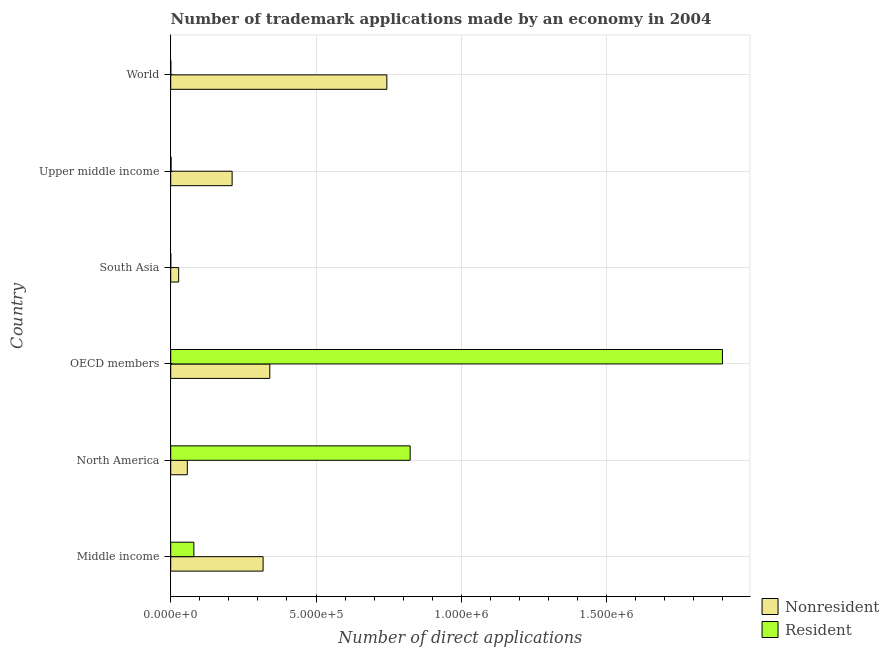How many groups of bars are there?
Keep it short and to the point. 6. Are the number of bars per tick equal to the number of legend labels?
Ensure brevity in your answer.  Yes. Are the number of bars on each tick of the Y-axis equal?
Offer a very short reply. Yes. How many bars are there on the 2nd tick from the bottom?
Your answer should be very brief. 2. In how many cases, is the number of bars for a given country not equal to the number of legend labels?
Provide a succinct answer. 0. What is the number of trademark applications made by residents in World?
Make the answer very short. 202. Across all countries, what is the maximum number of trademark applications made by non residents?
Offer a terse response. 7.44e+05. Across all countries, what is the minimum number of trademark applications made by residents?
Your answer should be compact. 128. In which country was the number of trademark applications made by non residents maximum?
Your response must be concise. World. What is the total number of trademark applications made by residents in the graph?
Make the answer very short. 2.80e+06. What is the difference between the number of trademark applications made by non residents in South Asia and that in Upper middle income?
Offer a terse response. -1.84e+05. What is the difference between the number of trademark applications made by residents in World and the number of trademark applications made by non residents in OECD members?
Your response must be concise. -3.41e+05. What is the average number of trademark applications made by non residents per country?
Keep it short and to the point. 2.83e+05. What is the difference between the number of trademark applications made by residents and number of trademark applications made by non residents in Middle income?
Keep it short and to the point. -2.38e+05. In how many countries, is the number of trademark applications made by residents greater than 600000 ?
Make the answer very short. 2. What is the ratio of the number of trademark applications made by non residents in North America to that in World?
Make the answer very short. 0.08. Is the number of trademark applications made by residents in OECD members less than that in South Asia?
Your answer should be compact. No. Is the difference between the number of trademark applications made by residents in North America and Upper middle income greater than the difference between the number of trademark applications made by non residents in North America and Upper middle income?
Your answer should be compact. Yes. What is the difference between the highest and the second highest number of trademark applications made by non residents?
Give a very brief answer. 4.03e+05. What is the difference between the highest and the lowest number of trademark applications made by non residents?
Give a very brief answer. 7.16e+05. In how many countries, is the number of trademark applications made by residents greater than the average number of trademark applications made by residents taken over all countries?
Give a very brief answer. 2. What does the 1st bar from the top in OECD members represents?
Keep it short and to the point. Resident. What does the 1st bar from the bottom in World represents?
Make the answer very short. Nonresident. How many bars are there?
Provide a short and direct response. 12. How many countries are there in the graph?
Ensure brevity in your answer.  6. What is the difference between two consecutive major ticks on the X-axis?
Provide a succinct answer. 5.00e+05. Are the values on the major ticks of X-axis written in scientific E-notation?
Make the answer very short. Yes. Does the graph contain any zero values?
Your answer should be very brief. No. Does the graph contain grids?
Keep it short and to the point. Yes. Where does the legend appear in the graph?
Keep it short and to the point. Bottom right. How many legend labels are there?
Your answer should be very brief. 2. How are the legend labels stacked?
Make the answer very short. Vertical. What is the title of the graph?
Keep it short and to the point. Number of trademark applications made by an economy in 2004. Does "Under-5(male)" appear as one of the legend labels in the graph?
Provide a succinct answer. No. What is the label or title of the X-axis?
Offer a very short reply. Number of direct applications. What is the Number of direct applications of Nonresident in Middle income?
Make the answer very short. 3.18e+05. What is the Number of direct applications in Resident in Middle income?
Offer a very short reply. 7.97e+04. What is the Number of direct applications in Nonresident in North America?
Offer a very short reply. 5.71e+04. What is the Number of direct applications in Resident in North America?
Your response must be concise. 8.24e+05. What is the Number of direct applications in Nonresident in OECD members?
Offer a terse response. 3.41e+05. What is the Number of direct applications in Resident in OECD members?
Your answer should be compact. 1.90e+06. What is the Number of direct applications in Nonresident in South Asia?
Offer a very short reply. 2.73e+04. What is the Number of direct applications of Resident in South Asia?
Give a very brief answer. 128. What is the Number of direct applications in Nonresident in Upper middle income?
Offer a terse response. 2.11e+05. What is the Number of direct applications in Resident in Upper middle income?
Offer a terse response. 1266. What is the Number of direct applications of Nonresident in World?
Make the answer very short. 7.44e+05. What is the Number of direct applications in Resident in World?
Offer a very short reply. 202. Across all countries, what is the maximum Number of direct applications in Nonresident?
Provide a short and direct response. 7.44e+05. Across all countries, what is the maximum Number of direct applications in Resident?
Offer a terse response. 1.90e+06. Across all countries, what is the minimum Number of direct applications of Nonresident?
Your answer should be very brief. 2.73e+04. Across all countries, what is the minimum Number of direct applications in Resident?
Your answer should be compact. 128. What is the total Number of direct applications in Nonresident in the graph?
Your answer should be compact. 1.70e+06. What is the total Number of direct applications in Resident in the graph?
Give a very brief answer. 2.80e+06. What is the difference between the Number of direct applications in Nonresident in Middle income and that in North America?
Provide a succinct answer. 2.61e+05. What is the difference between the Number of direct applications in Resident in Middle income and that in North America?
Ensure brevity in your answer.  -7.44e+05. What is the difference between the Number of direct applications of Nonresident in Middle income and that in OECD members?
Give a very brief answer. -2.30e+04. What is the difference between the Number of direct applications in Resident in Middle income and that in OECD members?
Keep it short and to the point. -1.82e+06. What is the difference between the Number of direct applications of Nonresident in Middle income and that in South Asia?
Your answer should be very brief. 2.91e+05. What is the difference between the Number of direct applications of Resident in Middle income and that in South Asia?
Give a very brief answer. 7.95e+04. What is the difference between the Number of direct applications of Nonresident in Middle income and that in Upper middle income?
Your answer should be very brief. 1.07e+05. What is the difference between the Number of direct applications in Resident in Middle income and that in Upper middle income?
Ensure brevity in your answer.  7.84e+04. What is the difference between the Number of direct applications of Nonresident in Middle income and that in World?
Ensure brevity in your answer.  -4.26e+05. What is the difference between the Number of direct applications in Resident in Middle income and that in World?
Provide a short and direct response. 7.95e+04. What is the difference between the Number of direct applications of Nonresident in North America and that in OECD members?
Provide a succinct answer. -2.84e+05. What is the difference between the Number of direct applications in Resident in North America and that in OECD members?
Provide a succinct answer. -1.07e+06. What is the difference between the Number of direct applications in Nonresident in North America and that in South Asia?
Provide a succinct answer. 2.97e+04. What is the difference between the Number of direct applications of Resident in North America and that in South Asia?
Ensure brevity in your answer.  8.24e+05. What is the difference between the Number of direct applications in Nonresident in North America and that in Upper middle income?
Offer a terse response. -1.54e+05. What is the difference between the Number of direct applications in Resident in North America and that in Upper middle income?
Make the answer very short. 8.23e+05. What is the difference between the Number of direct applications in Nonresident in North America and that in World?
Make the answer very short. -6.87e+05. What is the difference between the Number of direct applications in Resident in North America and that in World?
Make the answer very short. 8.24e+05. What is the difference between the Number of direct applications of Nonresident in OECD members and that in South Asia?
Provide a short and direct response. 3.14e+05. What is the difference between the Number of direct applications in Resident in OECD members and that in South Asia?
Make the answer very short. 1.90e+06. What is the difference between the Number of direct applications of Nonresident in OECD members and that in Upper middle income?
Provide a succinct answer. 1.30e+05. What is the difference between the Number of direct applications of Resident in OECD members and that in Upper middle income?
Your response must be concise. 1.90e+06. What is the difference between the Number of direct applications of Nonresident in OECD members and that in World?
Make the answer very short. -4.03e+05. What is the difference between the Number of direct applications in Resident in OECD members and that in World?
Offer a very short reply. 1.90e+06. What is the difference between the Number of direct applications in Nonresident in South Asia and that in Upper middle income?
Your answer should be very brief. -1.84e+05. What is the difference between the Number of direct applications in Resident in South Asia and that in Upper middle income?
Offer a terse response. -1138. What is the difference between the Number of direct applications of Nonresident in South Asia and that in World?
Give a very brief answer. -7.16e+05. What is the difference between the Number of direct applications of Resident in South Asia and that in World?
Make the answer very short. -74. What is the difference between the Number of direct applications of Nonresident in Upper middle income and that in World?
Your response must be concise. -5.32e+05. What is the difference between the Number of direct applications of Resident in Upper middle income and that in World?
Offer a very short reply. 1064. What is the difference between the Number of direct applications in Nonresident in Middle income and the Number of direct applications in Resident in North America?
Your answer should be very brief. -5.06e+05. What is the difference between the Number of direct applications in Nonresident in Middle income and the Number of direct applications in Resident in OECD members?
Offer a very short reply. -1.58e+06. What is the difference between the Number of direct applications of Nonresident in Middle income and the Number of direct applications of Resident in South Asia?
Keep it short and to the point. 3.18e+05. What is the difference between the Number of direct applications of Nonresident in Middle income and the Number of direct applications of Resident in Upper middle income?
Give a very brief answer. 3.17e+05. What is the difference between the Number of direct applications of Nonresident in Middle income and the Number of direct applications of Resident in World?
Your answer should be compact. 3.18e+05. What is the difference between the Number of direct applications of Nonresident in North America and the Number of direct applications of Resident in OECD members?
Your answer should be compact. -1.84e+06. What is the difference between the Number of direct applications of Nonresident in North America and the Number of direct applications of Resident in South Asia?
Provide a succinct answer. 5.70e+04. What is the difference between the Number of direct applications in Nonresident in North America and the Number of direct applications in Resident in Upper middle income?
Give a very brief answer. 5.58e+04. What is the difference between the Number of direct applications of Nonresident in North America and the Number of direct applications of Resident in World?
Ensure brevity in your answer.  5.69e+04. What is the difference between the Number of direct applications in Nonresident in OECD members and the Number of direct applications in Resident in South Asia?
Make the answer very short. 3.41e+05. What is the difference between the Number of direct applications in Nonresident in OECD members and the Number of direct applications in Resident in Upper middle income?
Your response must be concise. 3.40e+05. What is the difference between the Number of direct applications in Nonresident in OECD members and the Number of direct applications in Resident in World?
Ensure brevity in your answer.  3.41e+05. What is the difference between the Number of direct applications of Nonresident in South Asia and the Number of direct applications of Resident in Upper middle income?
Keep it short and to the point. 2.61e+04. What is the difference between the Number of direct applications of Nonresident in South Asia and the Number of direct applications of Resident in World?
Your answer should be compact. 2.71e+04. What is the difference between the Number of direct applications in Nonresident in Upper middle income and the Number of direct applications in Resident in World?
Keep it short and to the point. 2.11e+05. What is the average Number of direct applications of Nonresident per country?
Provide a succinct answer. 2.83e+05. What is the average Number of direct applications of Resident per country?
Your answer should be compact. 4.67e+05. What is the difference between the Number of direct applications in Nonresident and Number of direct applications in Resident in Middle income?
Offer a terse response. 2.38e+05. What is the difference between the Number of direct applications of Nonresident and Number of direct applications of Resident in North America?
Provide a short and direct response. -7.67e+05. What is the difference between the Number of direct applications in Nonresident and Number of direct applications in Resident in OECD members?
Ensure brevity in your answer.  -1.56e+06. What is the difference between the Number of direct applications of Nonresident and Number of direct applications of Resident in South Asia?
Your response must be concise. 2.72e+04. What is the difference between the Number of direct applications in Nonresident and Number of direct applications in Resident in Upper middle income?
Provide a succinct answer. 2.10e+05. What is the difference between the Number of direct applications in Nonresident and Number of direct applications in Resident in World?
Your answer should be very brief. 7.43e+05. What is the ratio of the Number of direct applications of Nonresident in Middle income to that in North America?
Give a very brief answer. 5.57. What is the ratio of the Number of direct applications in Resident in Middle income to that in North America?
Your response must be concise. 0.1. What is the ratio of the Number of direct applications of Nonresident in Middle income to that in OECD members?
Your answer should be very brief. 0.93. What is the ratio of the Number of direct applications of Resident in Middle income to that in OECD members?
Your answer should be compact. 0.04. What is the ratio of the Number of direct applications in Nonresident in Middle income to that in South Asia?
Offer a terse response. 11.62. What is the ratio of the Number of direct applications of Resident in Middle income to that in South Asia?
Offer a terse response. 622.37. What is the ratio of the Number of direct applications in Nonresident in Middle income to that in Upper middle income?
Offer a terse response. 1.5. What is the ratio of the Number of direct applications of Resident in Middle income to that in Upper middle income?
Offer a very short reply. 62.92. What is the ratio of the Number of direct applications in Nonresident in Middle income to that in World?
Your answer should be very brief. 0.43. What is the ratio of the Number of direct applications of Resident in Middle income to that in World?
Offer a terse response. 394.37. What is the ratio of the Number of direct applications in Nonresident in North America to that in OECD members?
Your answer should be compact. 0.17. What is the ratio of the Number of direct applications of Resident in North America to that in OECD members?
Provide a succinct answer. 0.43. What is the ratio of the Number of direct applications in Nonresident in North America to that in South Asia?
Your answer should be very brief. 2.09. What is the ratio of the Number of direct applications in Resident in North America to that in South Asia?
Your answer should be very brief. 6436.41. What is the ratio of the Number of direct applications in Nonresident in North America to that in Upper middle income?
Provide a short and direct response. 0.27. What is the ratio of the Number of direct applications of Resident in North America to that in Upper middle income?
Your answer should be compact. 650.76. What is the ratio of the Number of direct applications of Nonresident in North America to that in World?
Your answer should be very brief. 0.08. What is the ratio of the Number of direct applications of Resident in North America to that in World?
Give a very brief answer. 4078.52. What is the ratio of the Number of direct applications in Nonresident in OECD members to that in South Asia?
Give a very brief answer. 12.47. What is the ratio of the Number of direct applications of Resident in OECD members to that in South Asia?
Your answer should be compact. 1.48e+04. What is the ratio of the Number of direct applications of Nonresident in OECD members to that in Upper middle income?
Your answer should be very brief. 1.61. What is the ratio of the Number of direct applications of Resident in OECD members to that in Upper middle income?
Provide a short and direct response. 1499.45. What is the ratio of the Number of direct applications of Nonresident in OECD members to that in World?
Provide a succinct answer. 0.46. What is the ratio of the Number of direct applications in Resident in OECD members to that in World?
Keep it short and to the point. 9397.53. What is the ratio of the Number of direct applications in Nonresident in South Asia to that in Upper middle income?
Provide a succinct answer. 0.13. What is the ratio of the Number of direct applications in Resident in South Asia to that in Upper middle income?
Provide a short and direct response. 0.1. What is the ratio of the Number of direct applications of Nonresident in South Asia to that in World?
Your answer should be very brief. 0.04. What is the ratio of the Number of direct applications in Resident in South Asia to that in World?
Make the answer very short. 0.63. What is the ratio of the Number of direct applications of Nonresident in Upper middle income to that in World?
Your answer should be very brief. 0.28. What is the ratio of the Number of direct applications of Resident in Upper middle income to that in World?
Give a very brief answer. 6.27. What is the difference between the highest and the second highest Number of direct applications of Nonresident?
Your answer should be compact. 4.03e+05. What is the difference between the highest and the second highest Number of direct applications of Resident?
Keep it short and to the point. 1.07e+06. What is the difference between the highest and the lowest Number of direct applications of Nonresident?
Give a very brief answer. 7.16e+05. What is the difference between the highest and the lowest Number of direct applications of Resident?
Ensure brevity in your answer.  1.90e+06. 